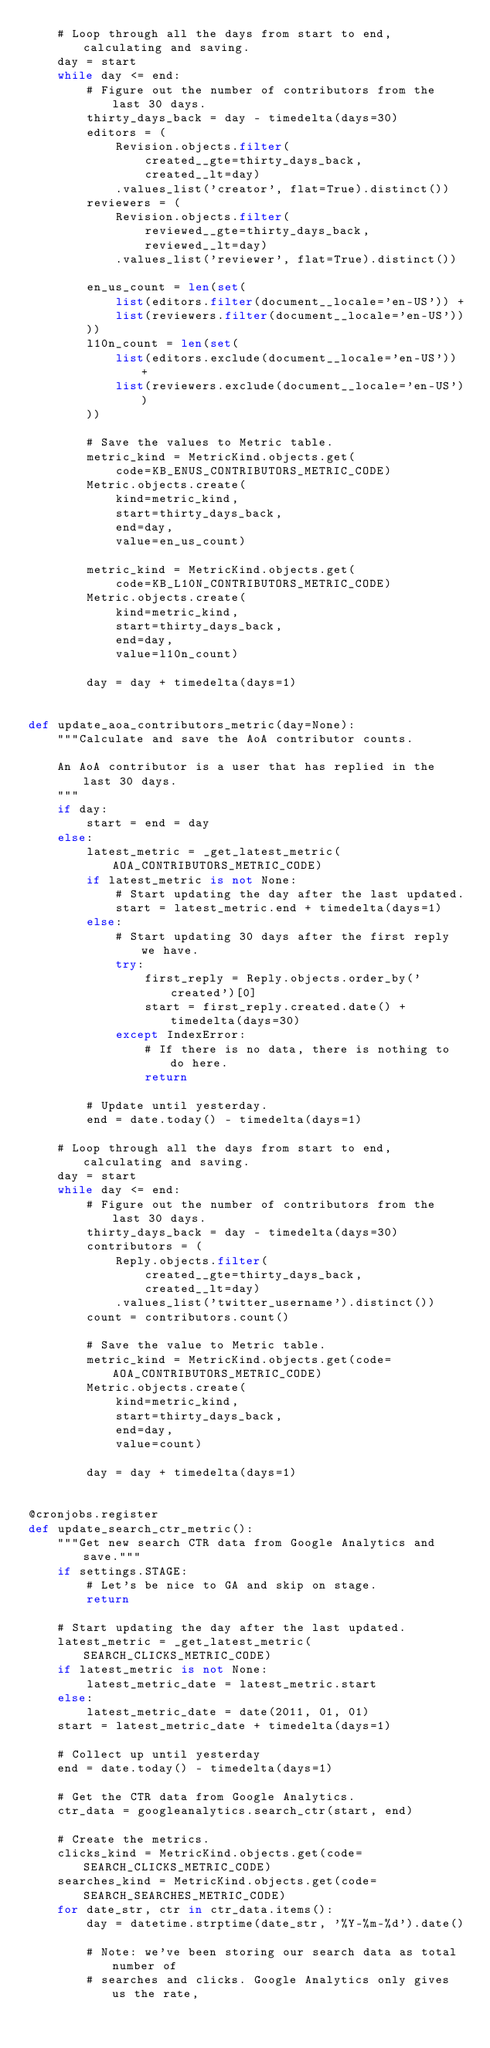Convert code to text. <code><loc_0><loc_0><loc_500><loc_500><_Python_>    # Loop through all the days from start to end, calculating and saving.
    day = start
    while day <= end:
        # Figure out the number of contributors from the last 30 days.
        thirty_days_back = day - timedelta(days=30)
        editors = (
            Revision.objects.filter(
                created__gte=thirty_days_back,
                created__lt=day)
            .values_list('creator', flat=True).distinct())
        reviewers = (
            Revision.objects.filter(
                reviewed__gte=thirty_days_back,
                reviewed__lt=day)
            .values_list('reviewer', flat=True).distinct())

        en_us_count = len(set(
            list(editors.filter(document__locale='en-US')) +
            list(reviewers.filter(document__locale='en-US'))
        ))
        l10n_count = len(set(
            list(editors.exclude(document__locale='en-US')) +
            list(reviewers.exclude(document__locale='en-US'))
        ))

        # Save the values to Metric table.
        metric_kind = MetricKind.objects.get(
            code=KB_ENUS_CONTRIBUTORS_METRIC_CODE)
        Metric.objects.create(
            kind=metric_kind,
            start=thirty_days_back,
            end=day,
            value=en_us_count)

        metric_kind = MetricKind.objects.get(
            code=KB_L10N_CONTRIBUTORS_METRIC_CODE)
        Metric.objects.create(
            kind=metric_kind,
            start=thirty_days_back,
            end=day,
            value=l10n_count)

        day = day + timedelta(days=1)


def update_aoa_contributors_metric(day=None):
    """Calculate and save the AoA contributor counts.

    An AoA contributor is a user that has replied in the last 30 days.
    """
    if day:
        start = end = day
    else:
        latest_metric = _get_latest_metric(AOA_CONTRIBUTORS_METRIC_CODE)
        if latest_metric is not None:
            # Start updating the day after the last updated.
            start = latest_metric.end + timedelta(days=1)
        else:
            # Start updating 30 days after the first reply we have.
            try:
                first_reply = Reply.objects.order_by('created')[0]
                start = first_reply.created.date() + timedelta(days=30)
            except IndexError:
                # If there is no data, there is nothing to do here.
                return

        # Update until yesterday.
        end = date.today() - timedelta(days=1)

    # Loop through all the days from start to end, calculating and saving.
    day = start
    while day <= end:
        # Figure out the number of contributors from the last 30 days.
        thirty_days_back = day - timedelta(days=30)
        contributors = (
            Reply.objects.filter(
                created__gte=thirty_days_back,
                created__lt=day)
            .values_list('twitter_username').distinct())
        count = contributors.count()

        # Save the value to Metric table.
        metric_kind = MetricKind.objects.get(code=AOA_CONTRIBUTORS_METRIC_CODE)
        Metric.objects.create(
            kind=metric_kind,
            start=thirty_days_back,
            end=day,
            value=count)

        day = day + timedelta(days=1)


@cronjobs.register
def update_search_ctr_metric():
    """Get new search CTR data from Google Analytics and save."""
    if settings.STAGE:
        # Let's be nice to GA and skip on stage.
        return

    # Start updating the day after the last updated.
    latest_metric = _get_latest_metric(SEARCH_CLICKS_METRIC_CODE)
    if latest_metric is not None:
        latest_metric_date = latest_metric.start
    else:
        latest_metric_date = date(2011, 01, 01)
    start = latest_metric_date + timedelta(days=1)

    # Collect up until yesterday
    end = date.today() - timedelta(days=1)

    # Get the CTR data from Google Analytics.
    ctr_data = googleanalytics.search_ctr(start, end)

    # Create the metrics.
    clicks_kind = MetricKind.objects.get(code=SEARCH_CLICKS_METRIC_CODE)
    searches_kind = MetricKind.objects.get(code=SEARCH_SEARCHES_METRIC_CODE)
    for date_str, ctr in ctr_data.items():
        day = datetime.strptime(date_str, '%Y-%m-%d').date()

        # Note: we've been storing our search data as total number of
        # searches and clicks. Google Analytics only gives us the rate,</code> 